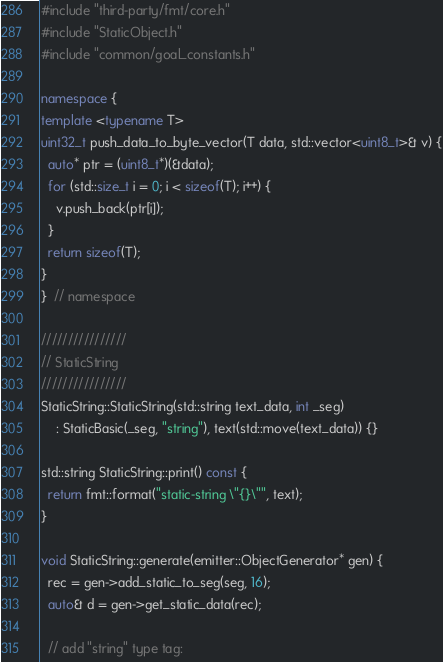Convert code to text. <code><loc_0><loc_0><loc_500><loc_500><_C++_>#include "third-party/fmt/core.h"
#include "StaticObject.h"
#include "common/goal_constants.h"

namespace {
template <typename T>
uint32_t push_data_to_byte_vector(T data, std::vector<uint8_t>& v) {
  auto* ptr = (uint8_t*)(&data);
  for (std::size_t i = 0; i < sizeof(T); i++) {
    v.push_back(ptr[i]);
  }
  return sizeof(T);
}
}  // namespace

////////////////
// StaticString
////////////////
StaticString::StaticString(std::string text_data, int _seg)
    : StaticBasic(_seg, "string"), text(std::move(text_data)) {}

std::string StaticString::print() const {
  return fmt::format("static-string \"{}\"", text);
}

void StaticString::generate(emitter::ObjectGenerator* gen) {
  rec = gen->add_static_to_seg(seg, 16);
  auto& d = gen->get_static_data(rec);

  // add "string" type tag:</code> 